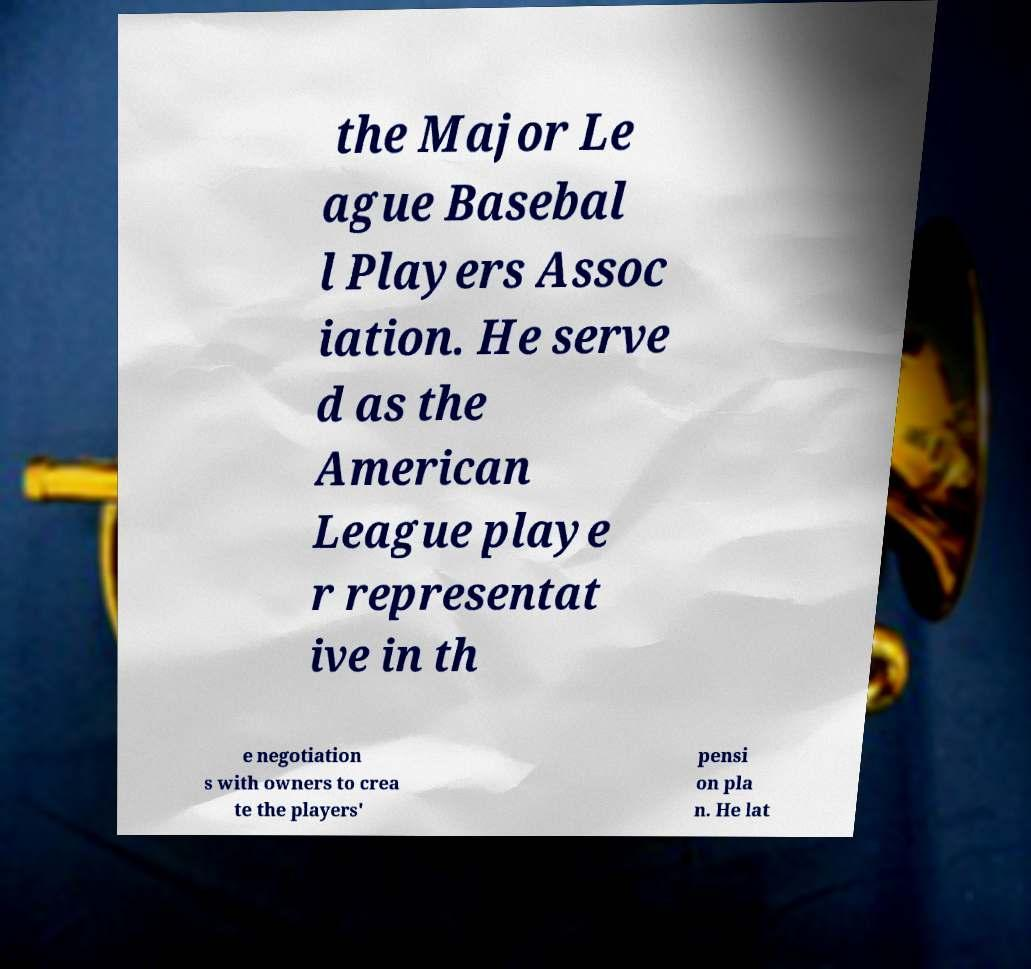I need the written content from this picture converted into text. Can you do that? the Major Le ague Basebal l Players Assoc iation. He serve d as the American League playe r representat ive in th e negotiation s with owners to crea te the players' pensi on pla n. He lat 